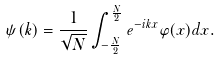<formula> <loc_0><loc_0><loc_500><loc_500>\psi ( k ) = \frac { 1 } { \sqrt { N } } \int _ { - \frac { N } { 2 } } ^ { \frac { N } { 2 } } e ^ { - i k x } \varphi ( x ) d x .</formula> 